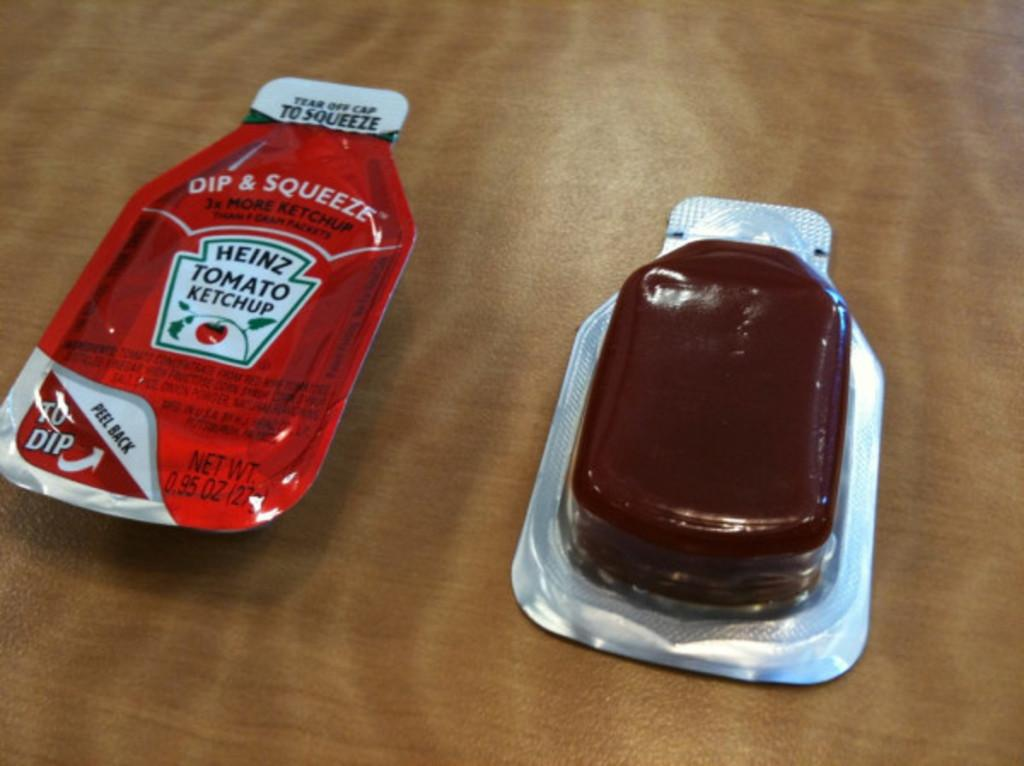<image>
Render a clear and concise summary of the photo. Packets of ketchup and barbecue sauce are on a table. 